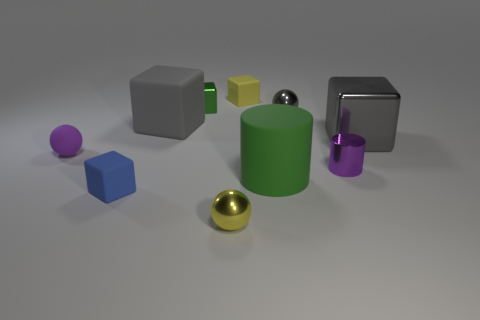There is a metallic object that is behind the small gray ball; what size is it?
Give a very brief answer. Small. What is the material of the yellow cube?
Ensure brevity in your answer.  Rubber. There is a small yellow thing in front of the green cylinder; does it have the same shape as the tiny green metal thing?
Provide a short and direct response. No. There is a shiny ball that is the same color as the large matte cube; what size is it?
Ensure brevity in your answer.  Small. Is there a yellow metallic object that has the same size as the blue matte object?
Provide a succinct answer. Yes. There is a yellow object that is behind the shiny ball in front of the gray metal ball; are there any objects in front of it?
Your response must be concise. Yes. There is a rubber cylinder; is it the same color as the small sphere that is in front of the rubber ball?
Your response must be concise. No. There is a gray cube that is behind the large block that is on the right side of the metal cube to the left of the big green matte cylinder; what is it made of?
Provide a succinct answer. Rubber. There is a yellow thing that is behind the small yellow metallic object; what shape is it?
Your answer should be compact. Cube. The purple ball that is made of the same material as the tiny blue cube is what size?
Your response must be concise. Small. 